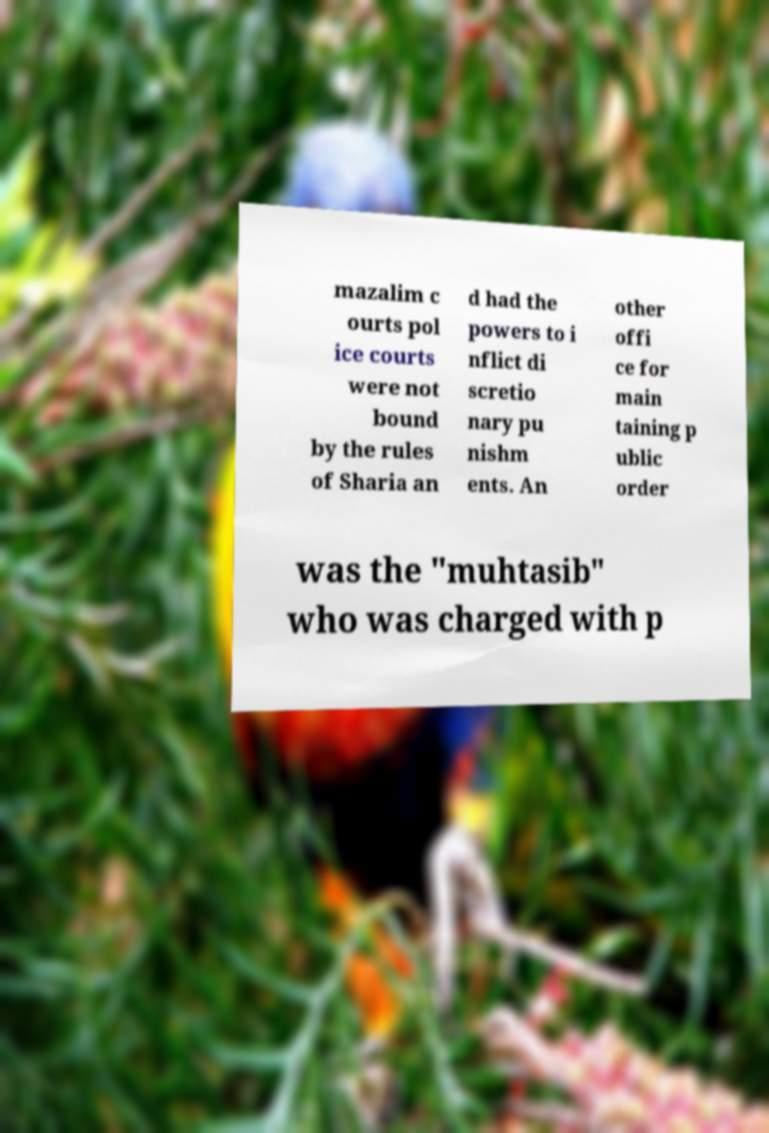Can you accurately transcribe the text from the provided image for me? mazalim c ourts pol ice courts were not bound by the rules of Sharia an d had the powers to i nflict di scretio nary pu nishm ents. An other offi ce for main taining p ublic order was the "muhtasib" who was charged with p 